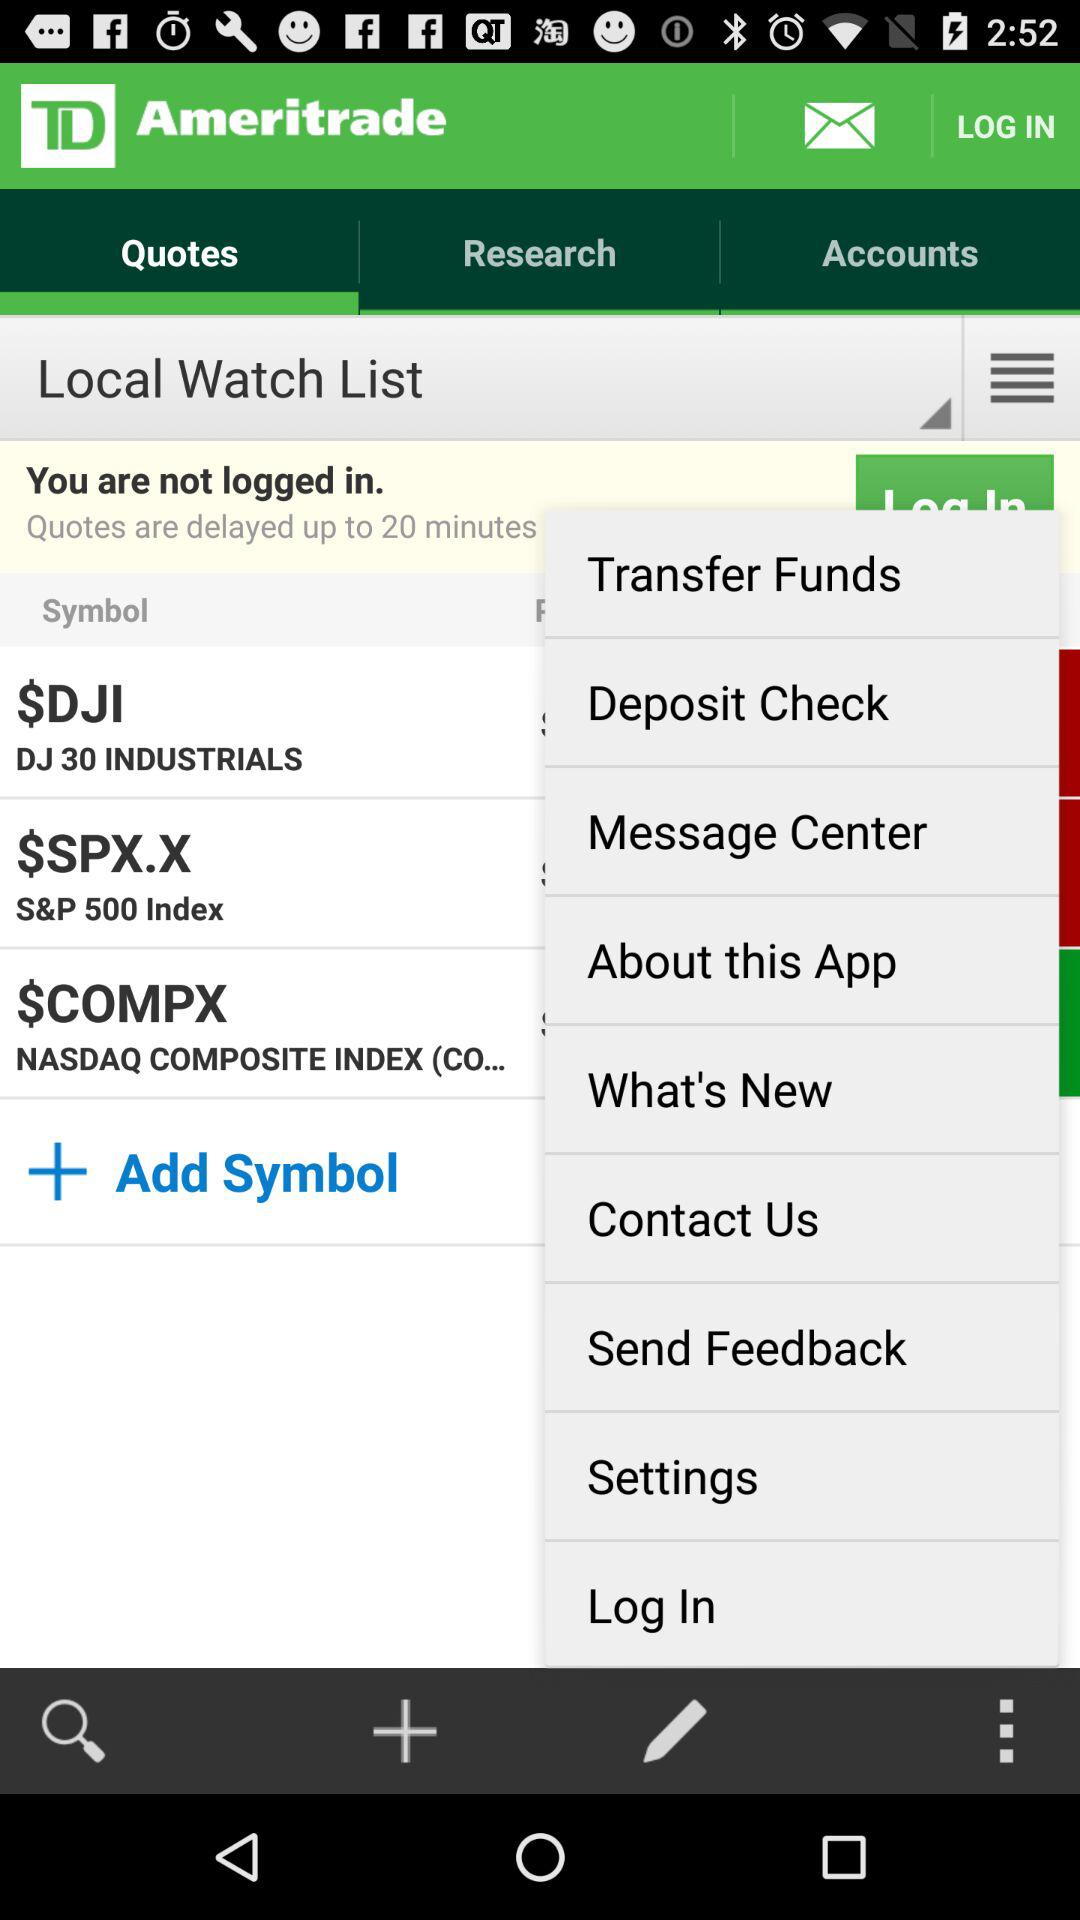Which tab is selected? The selected tab is "Quotes". 